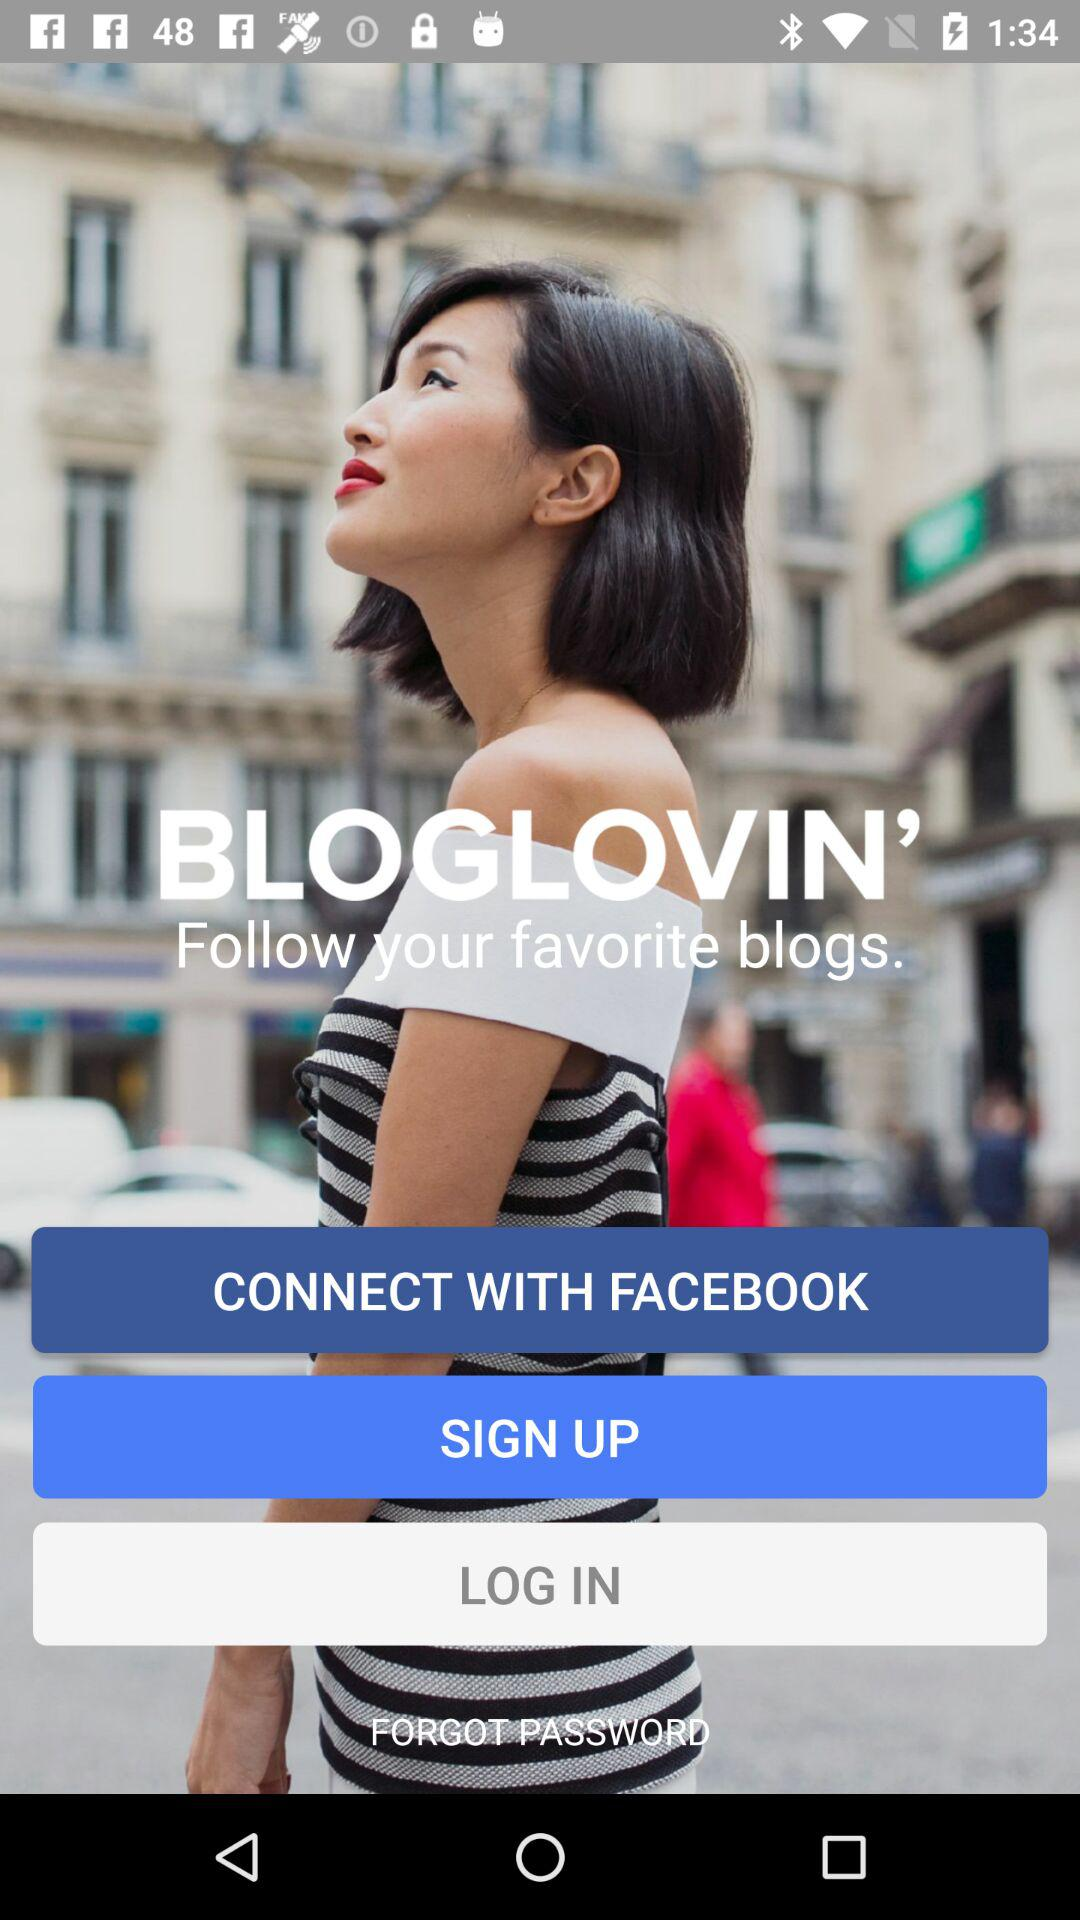What is the name of the application? The name of the application is "BLOGLOVIN'". 